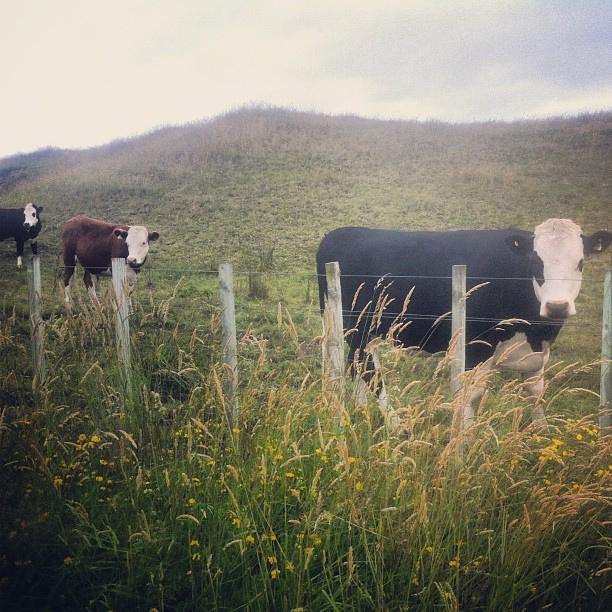Where are the cows?
Answer briefly. Pasture. What is the cow on the left looking at?
Be succinct. Fence. What color are the flowers in the foreground?
Quick response, please. Yellow. How many cows are there?
Quick response, please. 3. What animals are roaming?
Concise answer only. Cows. 